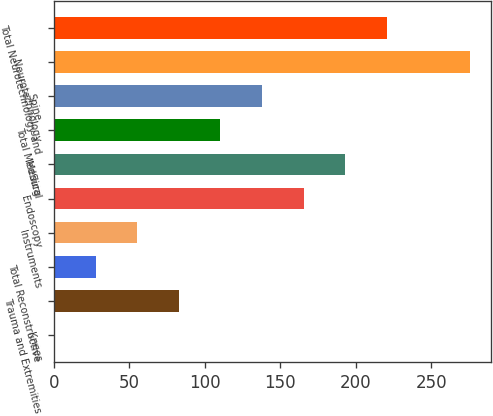<chart> <loc_0><loc_0><loc_500><loc_500><bar_chart><fcel>Knees<fcel>Trauma and Extremities<fcel>Total Reconstructive<fcel>Instruments<fcel>Endoscopy<fcel>Medical<fcel>Total MedSurg<fcel>Spine<fcel>Neurotechnology<fcel>Total Neurotechnology and<nl><fcel>0.1<fcel>82.78<fcel>27.66<fcel>55.22<fcel>165.46<fcel>193.02<fcel>110.34<fcel>137.9<fcel>275.7<fcel>220.58<nl></chart> 